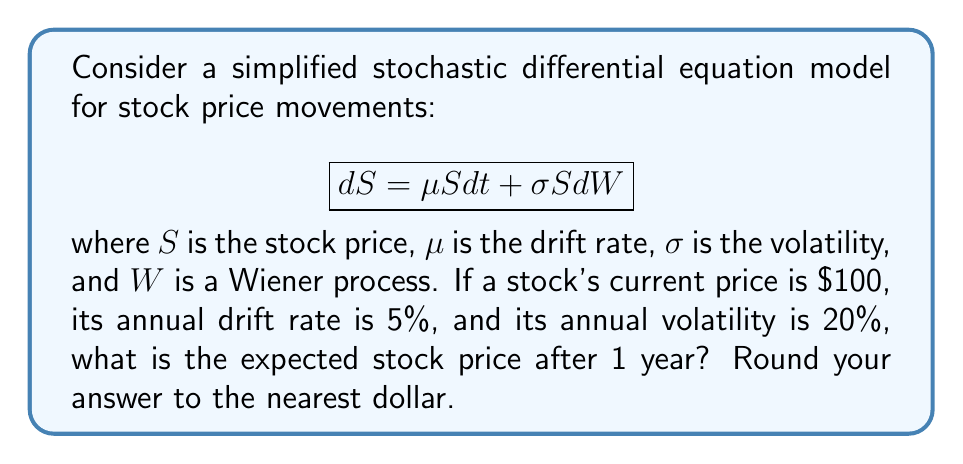Give your solution to this math problem. To solve this problem, we need to understand the properties of the given stochastic differential equation (SDE) and its solution.

1. The SDE given is known as the geometric Brownian motion model, which is commonly used for modeling stock prices.

2. For this model, the expected value of the stock price at time $t$ is given by the formula:

   $$E[S_t] = S_0 e^{\mu t}$$

   where $S_0$ is the initial stock price, $\mu$ is the drift rate, and $t$ is the time in years.

3. In this case, we have:
   - $S_0 = 100$ (current stock price)
   - $\mu = 0.05$ (5% annual drift rate)
   - $t = 1$ (we're looking at the price after 1 year)

4. Let's substitute these values into the formula:

   $$E[S_1] = 100 e^{0.05 \cdot 1}$$

5. Now we can calculate:
   $$E[S_1] = 100 e^{0.05} \approx 100 \cdot 1.0513 \approx 105.13$$

6. Rounding to the nearest dollar, we get 105.

Note that the volatility $\sigma$ doesn't appear in this calculation because we're only interested in the expected value. The volatility would come into play if we were calculating probabilities of different price outcomes or constructing confidence intervals.
Answer: $105 